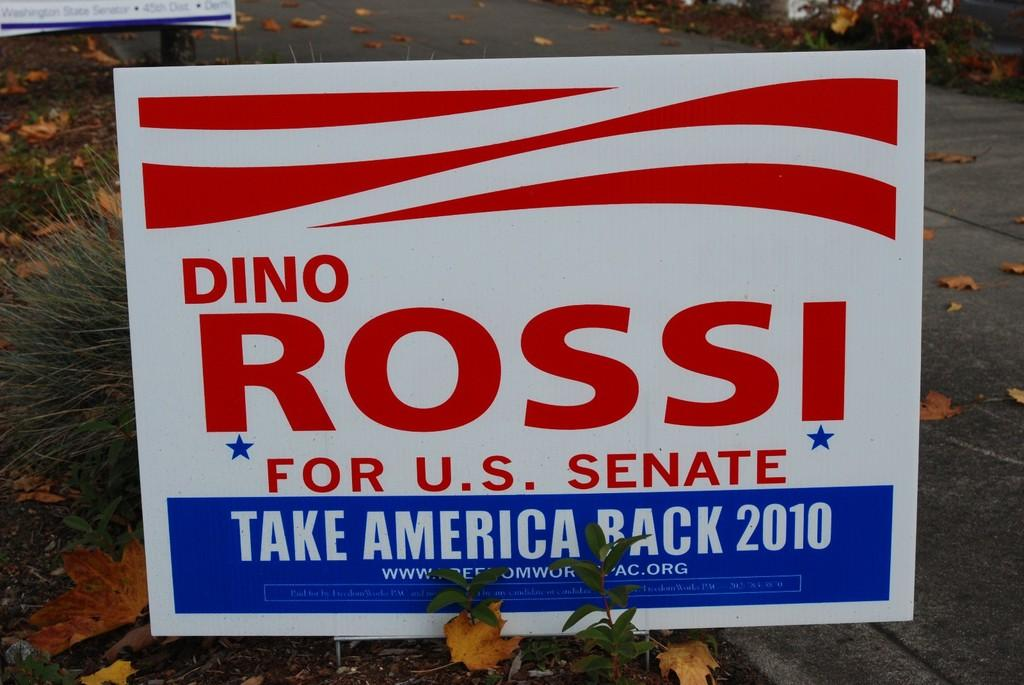<image>
Summarize the visual content of the image. Advertisement on the street that ass for people to vote for Dino Rossi. 